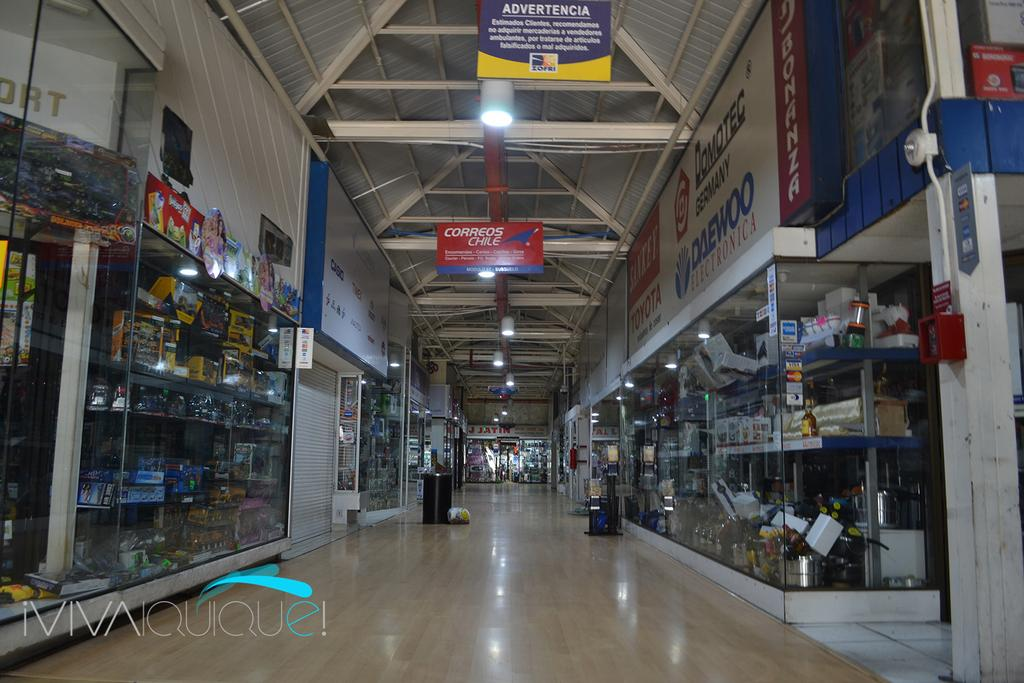Provide a one-sentence caption for the provided image. a sign at the top of the inside of a building that says 'advertencia'. 